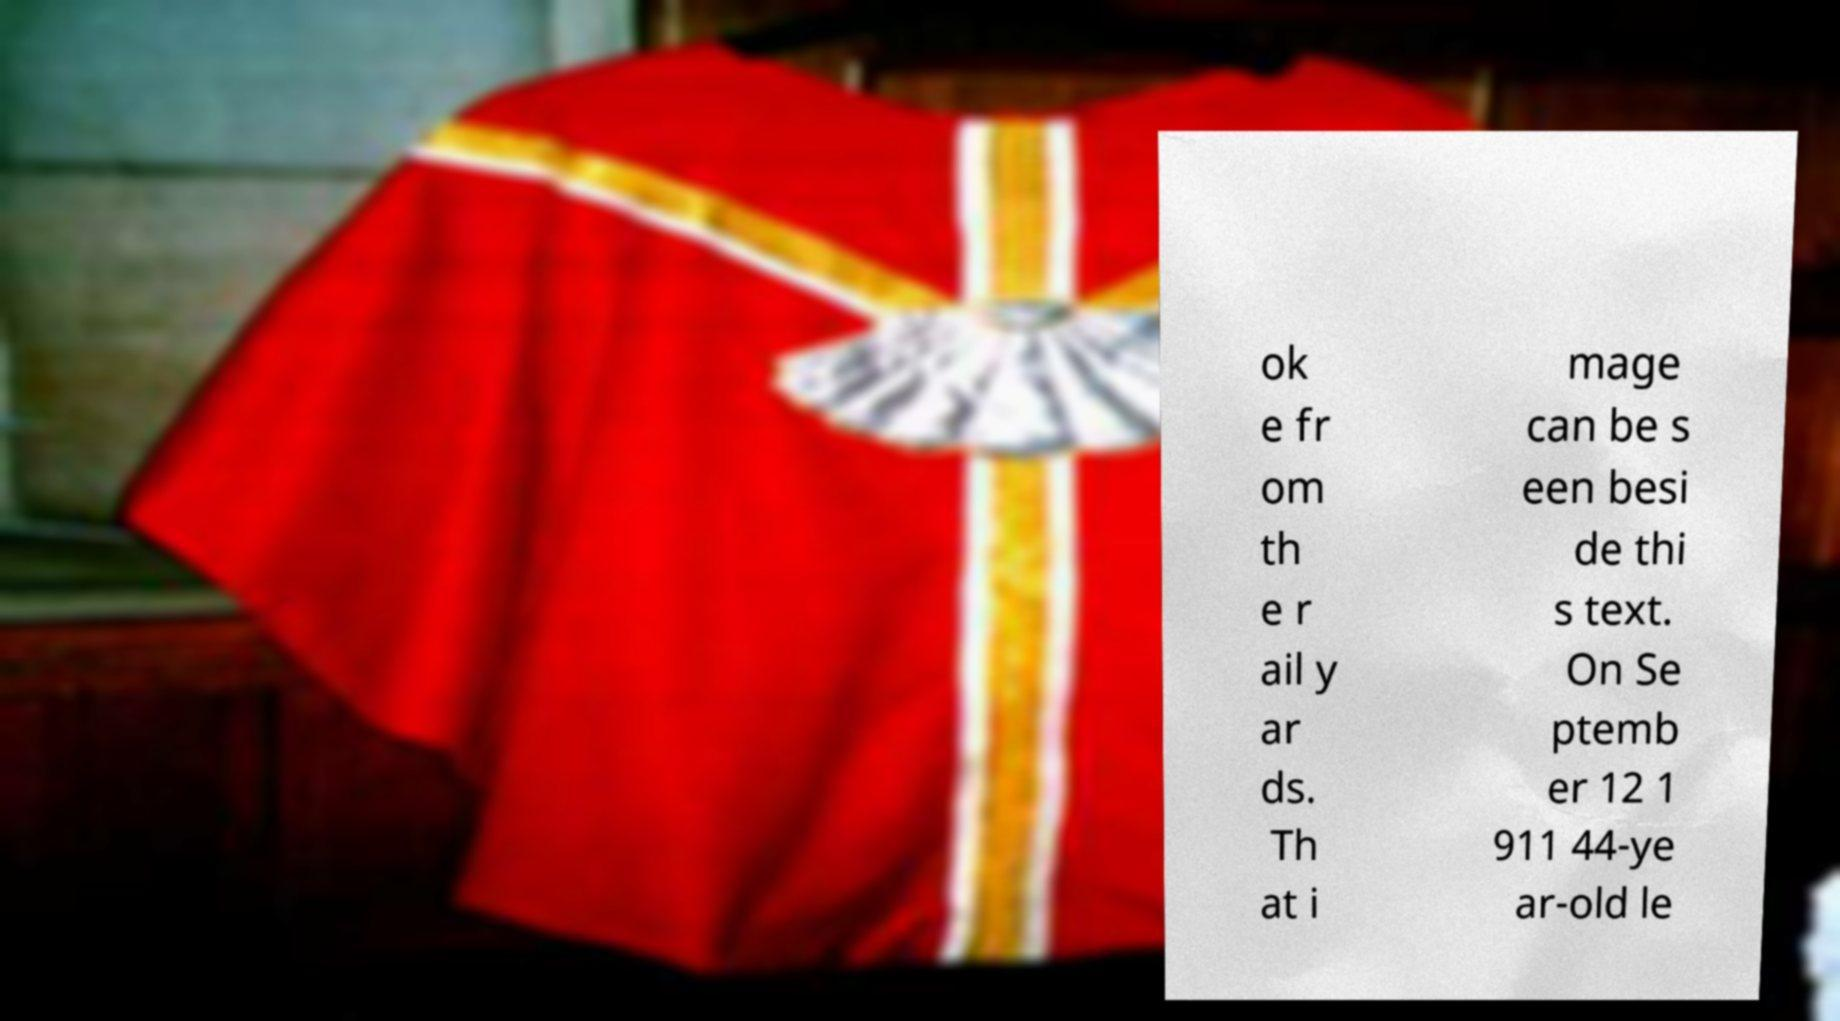For documentation purposes, I need the text within this image transcribed. Could you provide that? ok e fr om th e r ail y ar ds. Th at i mage can be s een besi de thi s text. On Se ptemb er 12 1 911 44-ye ar-old le 